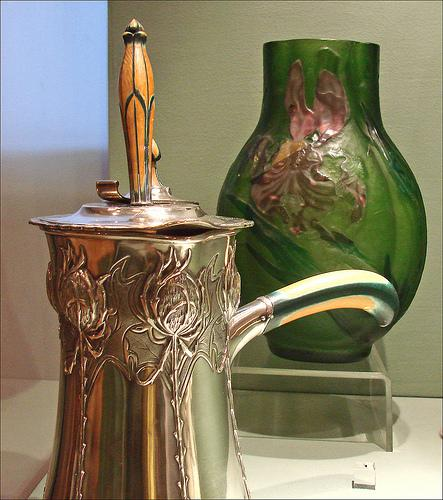Question: why is the green vase on a pedestal?
Choices:
A. For display.
B. To hold flowers.
C. To hold a plant.
D. As a paperweight.
Answer with the letter. Answer: A Question: how many items on display?
Choices:
A. Fifty.
B. Twenty.
C. One.
D. Two.
Answer with the letter. Answer: D Question: what design is on the items?
Choices:
A. Floral.
B. Stripes.
C. Polka dots.
D. Paisley.
Answer with the letter. Answer: A Question: who made these items?
Choices:
A. The little girl.
B. The artist.
C. The little boy.
D. The old man.
Answer with the letter. Answer: B Question: what color is the flower on the vase?
Choices:
A. Yellow.
B. Pink.
C. White.
D. Orange.
Answer with the letter. Answer: B Question: what is a vase for?
Choices:
A. To hold flowers.
B. For diplay.
C. To use as a paperweight.
D. To hold spare change.
Answer with the letter. Answer: A 